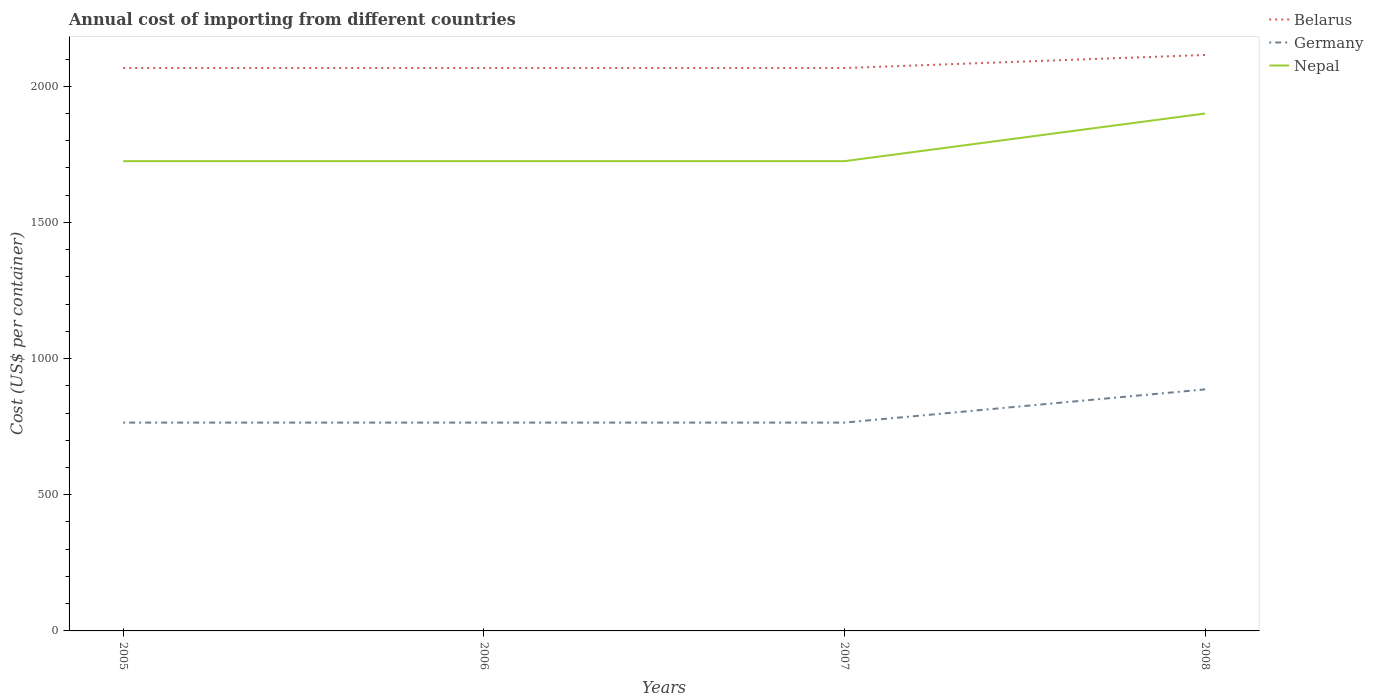Does the line corresponding to Germany intersect with the line corresponding to Nepal?
Your response must be concise. No. Across all years, what is the maximum total annual cost of importing in Nepal?
Your answer should be very brief. 1725. What is the difference between the highest and the second highest total annual cost of importing in Nepal?
Your response must be concise. 175. Is the total annual cost of importing in Belarus strictly greater than the total annual cost of importing in Germany over the years?
Keep it short and to the point. No. What is the difference between two consecutive major ticks on the Y-axis?
Make the answer very short. 500. Does the graph contain grids?
Your answer should be compact. No. Where does the legend appear in the graph?
Your response must be concise. Top right. What is the title of the graph?
Offer a terse response. Annual cost of importing from different countries. Does "Singapore" appear as one of the legend labels in the graph?
Provide a succinct answer. No. What is the label or title of the X-axis?
Provide a succinct answer. Years. What is the label or title of the Y-axis?
Keep it short and to the point. Cost (US$ per container). What is the Cost (US$ per container) of Belarus in 2005?
Your response must be concise. 2067. What is the Cost (US$ per container) of Germany in 2005?
Make the answer very short. 765. What is the Cost (US$ per container) in Nepal in 2005?
Your answer should be very brief. 1725. What is the Cost (US$ per container) in Belarus in 2006?
Ensure brevity in your answer.  2067. What is the Cost (US$ per container) in Germany in 2006?
Your answer should be compact. 765. What is the Cost (US$ per container) in Nepal in 2006?
Offer a very short reply. 1725. What is the Cost (US$ per container) in Belarus in 2007?
Provide a short and direct response. 2067. What is the Cost (US$ per container) of Germany in 2007?
Provide a short and direct response. 765. What is the Cost (US$ per container) in Nepal in 2007?
Give a very brief answer. 1725. What is the Cost (US$ per container) in Belarus in 2008?
Offer a terse response. 2115. What is the Cost (US$ per container) of Germany in 2008?
Keep it short and to the point. 887. What is the Cost (US$ per container) in Nepal in 2008?
Ensure brevity in your answer.  1900. Across all years, what is the maximum Cost (US$ per container) in Belarus?
Make the answer very short. 2115. Across all years, what is the maximum Cost (US$ per container) of Germany?
Provide a short and direct response. 887. Across all years, what is the maximum Cost (US$ per container) of Nepal?
Make the answer very short. 1900. Across all years, what is the minimum Cost (US$ per container) in Belarus?
Give a very brief answer. 2067. Across all years, what is the minimum Cost (US$ per container) in Germany?
Provide a succinct answer. 765. Across all years, what is the minimum Cost (US$ per container) in Nepal?
Your answer should be compact. 1725. What is the total Cost (US$ per container) in Belarus in the graph?
Give a very brief answer. 8316. What is the total Cost (US$ per container) in Germany in the graph?
Make the answer very short. 3182. What is the total Cost (US$ per container) of Nepal in the graph?
Offer a very short reply. 7075. What is the difference between the Cost (US$ per container) of Germany in 2005 and that in 2006?
Provide a succinct answer. 0. What is the difference between the Cost (US$ per container) of Nepal in 2005 and that in 2006?
Provide a short and direct response. 0. What is the difference between the Cost (US$ per container) of Belarus in 2005 and that in 2007?
Your answer should be very brief. 0. What is the difference between the Cost (US$ per container) of Nepal in 2005 and that in 2007?
Give a very brief answer. 0. What is the difference between the Cost (US$ per container) of Belarus in 2005 and that in 2008?
Make the answer very short. -48. What is the difference between the Cost (US$ per container) of Germany in 2005 and that in 2008?
Your response must be concise. -122. What is the difference between the Cost (US$ per container) in Nepal in 2005 and that in 2008?
Provide a succinct answer. -175. What is the difference between the Cost (US$ per container) of Nepal in 2006 and that in 2007?
Your answer should be very brief. 0. What is the difference between the Cost (US$ per container) of Belarus in 2006 and that in 2008?
Provide a short and direct response. -48. What is the difference between the Cost (US$ per container) of Germany in 2006 and that in 2008?
Offer a very short reply. -122. What is the difference between the Cost (US$ per container) of Nepal in 2006 and that in 2008?
Offer a very short reply. -175. What is the difference between the Cost (US$ per container) of Belarus in 2007 and that in 2008?
Your answer should be very brief. -48. What is the difference between the Cost (US$ per container) of Germany in 2007 and that in 2008?
Keep it short and to the point. -122. What is the difference between the Cost (US$ per container) of Nepal in 2007 and that in 2008?
Provide a short and direct response. -175. What is the difference between the Cost (US$ per container) of Belarus in 2005 and the Cost (US$ per container) of Germany in 2006?
Ensure brevity in your answer.  1302. What is the difference between the Cost (US$ per container) in Belarus in 2005 and the Cost (US$ per container) in Nepal in 2006?
Ensure brevity in your answer.  342. What is the difference between the Cost (US$ per container) of Germany in 2005 and the Cost (US$ per container) of Nepal in 2006?
Give a very brief answer. -960. What is the difference between the Cost (US$ per container) in Belarus in 2005 and the Cost (US$ per container) in Germany in 2007?
Your answer should be compact. 1302. What is the difference between the Cost (US$ per container) of Belarus in 2005 and the Cost (US$ per container) of Nepal in 2007?
Offer a very short reply. 342. What is the difference between the Cost (US$ per container) in Germany in 2005 and the Cost (US$ per container) in Nepal in 2007?
Your answer should be very brief. -960. What is the difference between the Cost (US$ per container) of Belarus in 2005 and the Cost (US$ per container) of Germany in 2008?
Ensure brevity in your answer.  1180. What is the difference between the Cost (US$ per container) of Belarus in 2005 and the Cost (US$ per container) of Nepal in 2008?
Give a very brief answer. 167. What is the difference between the Cost (US$ per container) in Germany in 2005 and the Cost (US$ per container) in Nepal in 2008?
Offer a very short reply. -1135. What is the difference between the Cost (US$ per container) in Belarus in 2006 and the Cost (US$ per container) in Germany in 2007?
Provide a succinct answer. 1302. What is the difference between the Cost (US$ per container) of Belarus in 2006 and the Cost (US$ per container) of Nepal in 2007?
Your response must be concise. 342. What is the difference between the Cost (US$ per container) of Germany in 2006 and the Cost (US$ per container) of Nepal in 2007?
Provide a succinct answer. -960. What is the difference between the Cost (US$ per container) in Belarus in 2006 and the Cost (US$ per container) in Germany in 2008?
Keep it short and to the point. 1180. What is the difference between the Cost (US$ per container) of Belarus in 2006 and the Cost (US$ per container) of Nepal in 2008?
Your answer should be very brief. 167. What is the difference between the Cost (US$ per container) in Germany in 2006 and the Cost (US$ per container) in Nepal in 2008?
Make the answer very short. -1135. What is the difference between the Cost (US$ per container) of Belarus in 2007 and the Cost (US$ per container) of Germany in 2008?
Provide a short and direct response. 1180. What is the difference between the Cost (US$ per container) in Belarus in 2007 and the Cost (US$ per container) in Nepal in 2008?
Provide a short and direct response. 167. What is the difference between the Cost (US$ per container) in Germany in 2007 and the Cost (US$ per container) in Nepal in 2008?
Provide a succinct answer. -1135. What is the average Cost (US$ per container) in Belarus per year?
Offer a terse response. 2079. What is the average Cost (US$ per container) of Germany per year?
Provide a short and direct response. 795.5. What is the average Cost (US$ per container) in Nepal per year?
Your answer should be compact. 1768.75. In the year 2005, what is the difference between the Cost (US$ per container) in Belarus and Cost (US$ per container) in Germany?
Provide a succinct answer. 1302. In the year 2005, what is the difference between the Cost (US$ per container) of Belarus and Cost (US$ per container) of Nepal?
Make the answer very short. 342. In the year 2005, what is the difference between the Cost (US$ per container) of Germany and Cost (US$ per container) of Nepal?
Offer a very short reply. -960. In the year 2006, what is the difference between the Cost (US$ per container) in Belarus and Cost (US$ per container) in Germany?
Keep it short and to the point. 1302. In the year 2006, what is the difference between the Cost (US$ per container) in Belarus and Cost (US$ per container) in Nepal?
Give a very brief answer. 342. In the year 2006, what is the difference between the Cost (US$ per container) in Germany and Cost (US$ per container) in Nepal?
Make the answer very short. -960. In the year 2007, what is the difference between the Cost (US$ per container) of Belarus and Cost (US$ per container) of Germany?
Ensure brevity in your answer.  1302. In the year 2007, what is the difference between the Cost (US$ per container) of Belarus and Cost (US$ per container) of Nepal?
Provide a short and direct response. 342. In the year 2007, what is the difference between the Cost (US$ per container) in Germany and Cost (US$ per container) in Nepal?
Your answer should be compact. -960. In the year 2008, what is the difference between the Cost (US$ per container) of Belarus and Cost (US$ per container) of Germany?
Your answer should be very brief. 1228. In the year 2008, what is the difference between the Cost (US$ per container) in Belarus and Cost (US$ per container) in Nepal?
Give a very brief answer. 215. In the year 2008, what is the difference between the Cost (US$ per container) of Germany and Cost (US$ per container) of Nepal?
Offer a very short reply. -1013. What is the ratio of the Cost (US$ per container) in Germany in 2005 to that in 2006?
Ensure brevity in your answer.  1. What is the ratio of the Cost (US$ per container) of Nepal in 2005 to that in 2006?
Ensure brevity in your answer.  1. What is the ratio of the Cost (US$ per container) of Germany in 2005 to that in 2007?
Your answer should be compact. 1. What is the ratio of the Cost (US$ per container) in Belarus in 2005 to that in 2008?
Offer a terse response. 0.98. What is the ratio of the Cost (US$ per container) of Germany in 2005 to that in 2008?
Make the answer very short. 0.86. What is the ratio of the Cost (US$ per container) of Nepal in 2005 to that in 2008?
Your answer should be compact. 0.91. What is the ratio of the Cost (US$ per container) of Belarus in 2006 to that in 2008?
Offer a terse response. 0.98. What is the ratio of the Cost (US$ per container) in Germany in 2006 to that in 2008?
Make the answer very short. 0.86. What is the ratio of the Cost (US$ per container) of Nepal in 2006 to that in 2008?
Provide a succinct answer. 0.91. What is the ratio of the Cost (US$ per container) in Belarus in 2007 to that in 2008?
Provide a succinct answer. 0.98. What is the ratio of the Cost (US$ per container) of Germany in 2007 to that in 2008?
Make the answer very short. 0.86. What is the ratio of the Cost (US$ per container) of Nepal in 2007 to that in 2008?
Ensure brevity in your answer.  0.91. What is the difference between the highest and the second highest Cost (US$ per container) in Germany?
Ensure brevity in your answer.  122. What is the difference between the highest and the second highest Cost (US$ per container) of Nepal?
Your answer should be very brief. 175. What is the difference between the highest and the lowest Cost (US$ per container) in Germany?
Provide a succinct answer. 122. What is the difference between the highest and the lowest Cost (US$ per container) of Nepal?
Your answer should be compact. 175. 